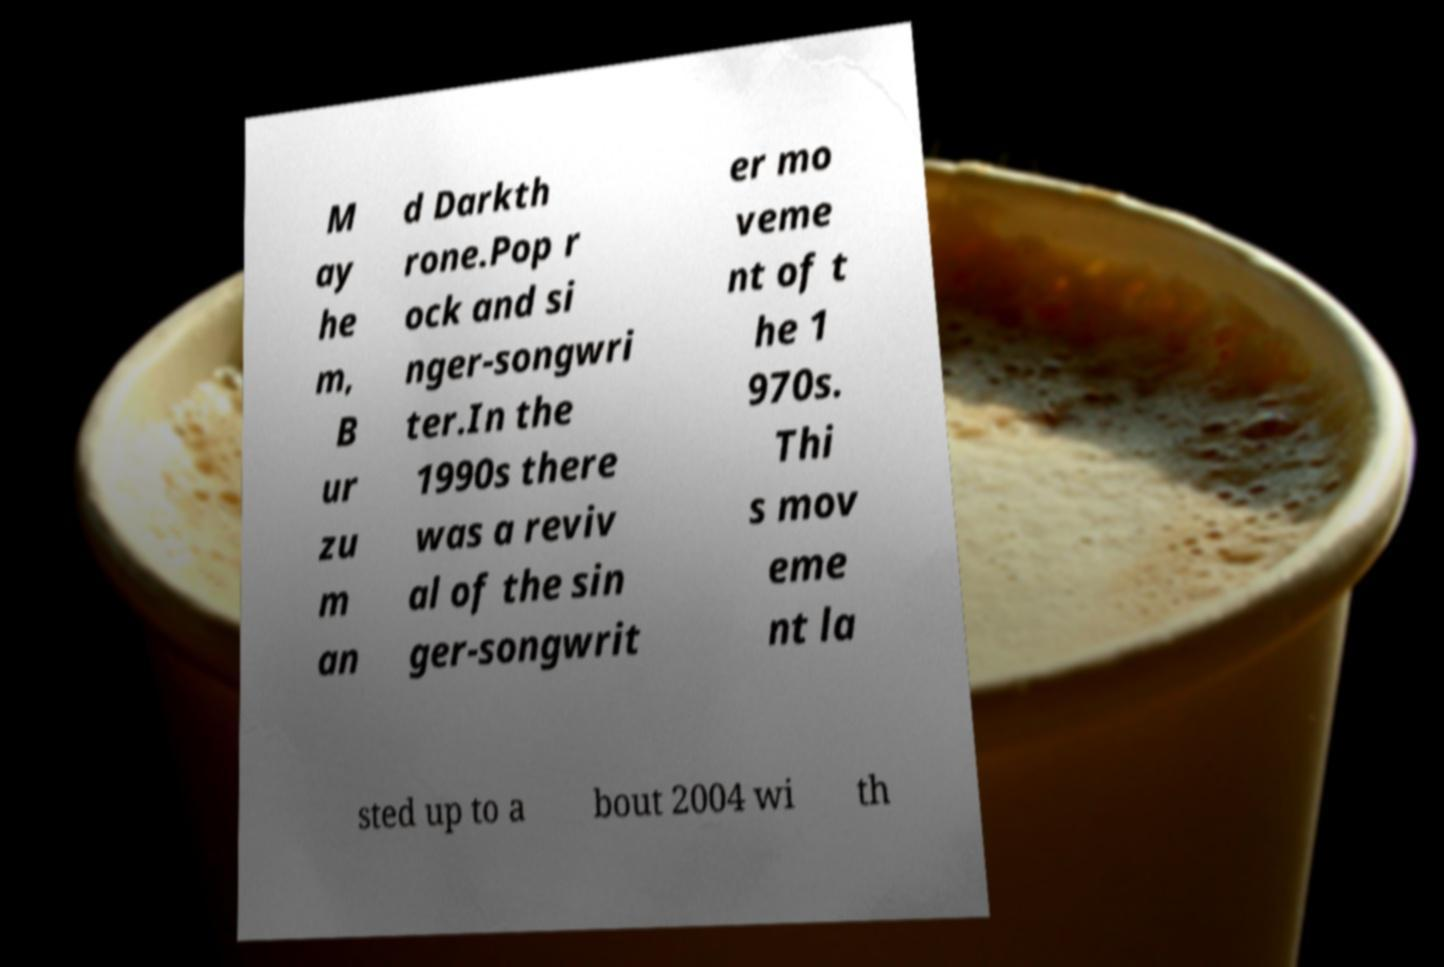For documentation purposes, I need the text within this image transcribed. Could you provide that? M ay he m, B ur zu m an d Darkth rone.Pop r ock and si nger-songwri ter.In the 1990s there was a reviv al of the sin ger-songwrit er mo veme nt of t he 1 970s. Thi s mov eme nt la sted up to a bout 2004 wi th 